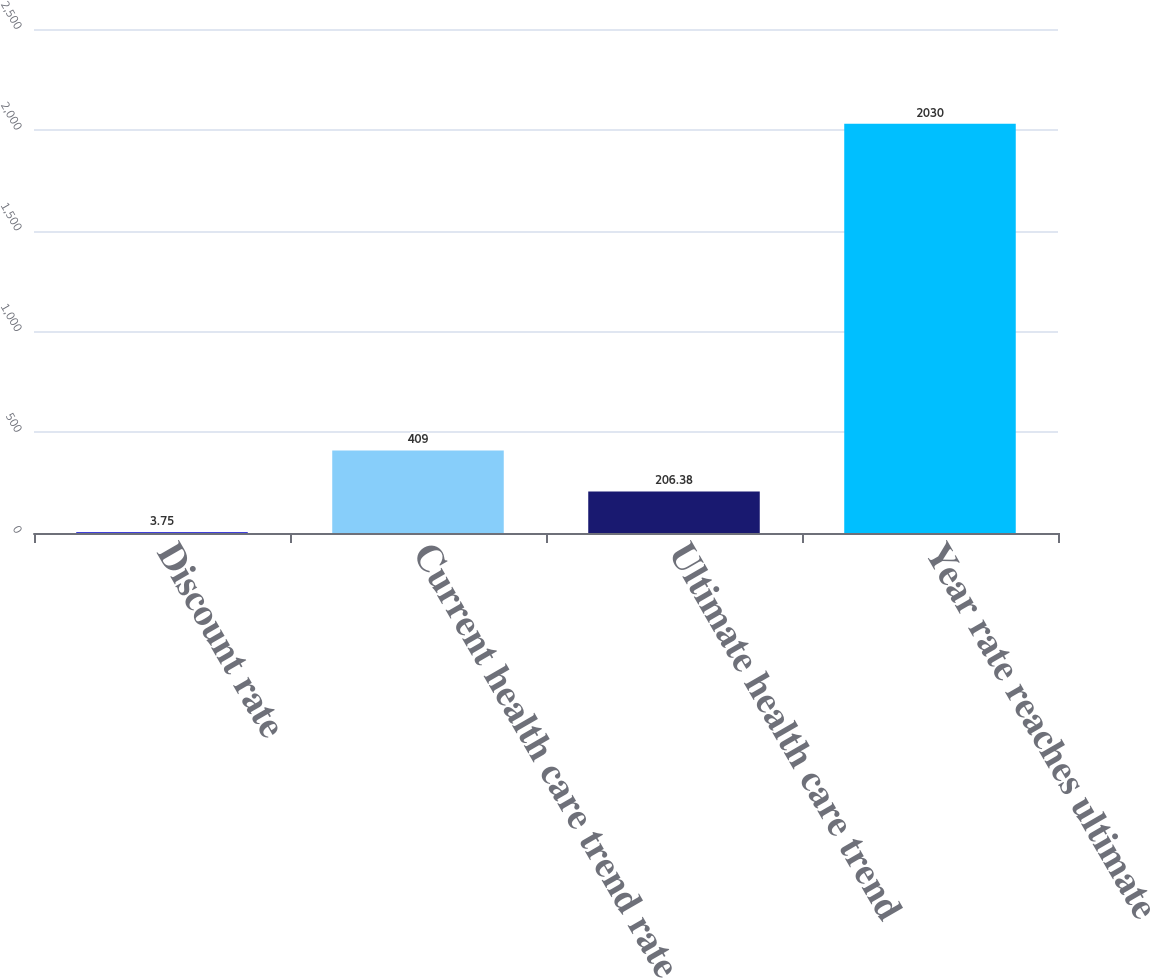Convert chart to OTSL. <chart><loc_0><loc_0><loc_500><loc_500><bar_chart><fcel>Discount rate<fcel>Current health care trend rate<fcel>Ultimate health care trend<fcel>Year rate reaches ultimate<nl><fcel>3.75<fcel>409<fcel>206.38<fcel>2030<nl></chart> 